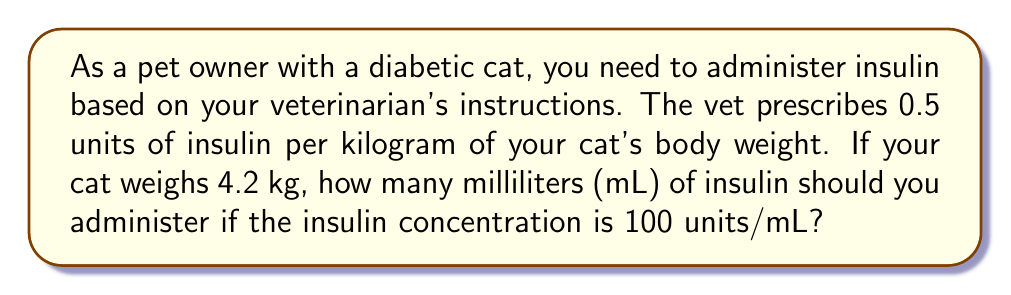Could you help me with this problem? Let's break this problem down into steps:

1. Calculate the total units of insulin needed:
   $$\text{Units of insulin} = \text{Weight (kg)} \times \text{Units per kg}$$
   $$\text{Units of insulin} = 4.2 \text{ kg} \times 0.5 \text{ units/kg} = 2.1 \text{ units}$$

2. Convert units to milliliters:
   We know that the insulin concentration is 100 units/mL.
   To convert units to mL, we use the following formula:
   $$\text{Volume (mL)} = \frac{\text{Total units needed}}{\text{Units per mL}}$$

   $$\text{Volume (mL)} = \frac{2.1 \text{ units}}{100 \text{ units/mL}}$$

3. Simplify the fraction:
   $$\text{Volume (mL)} = 0.021 \text{ mL}$$

Therefore, you should administer 0.021 mL of insulin to your cat.
Answer: $0.021 \text{ mL}$ 